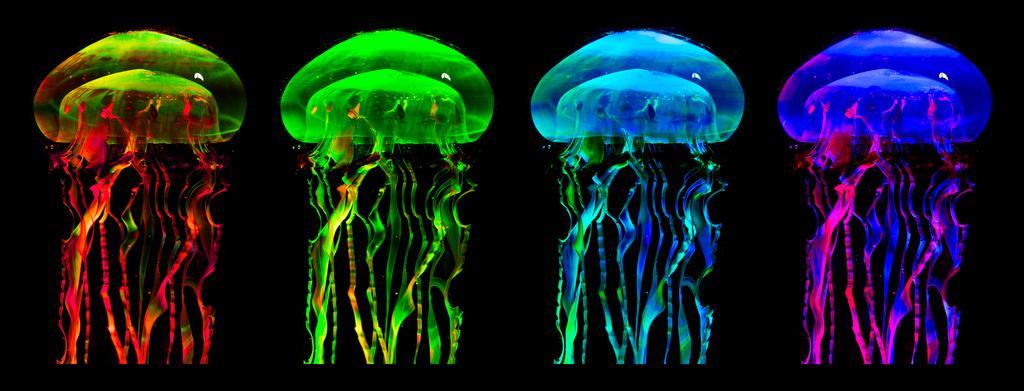Can you describe this image briefly? In the picture we can see a four jellyfishes with the colors green, yellow, blue and pink and blue. 